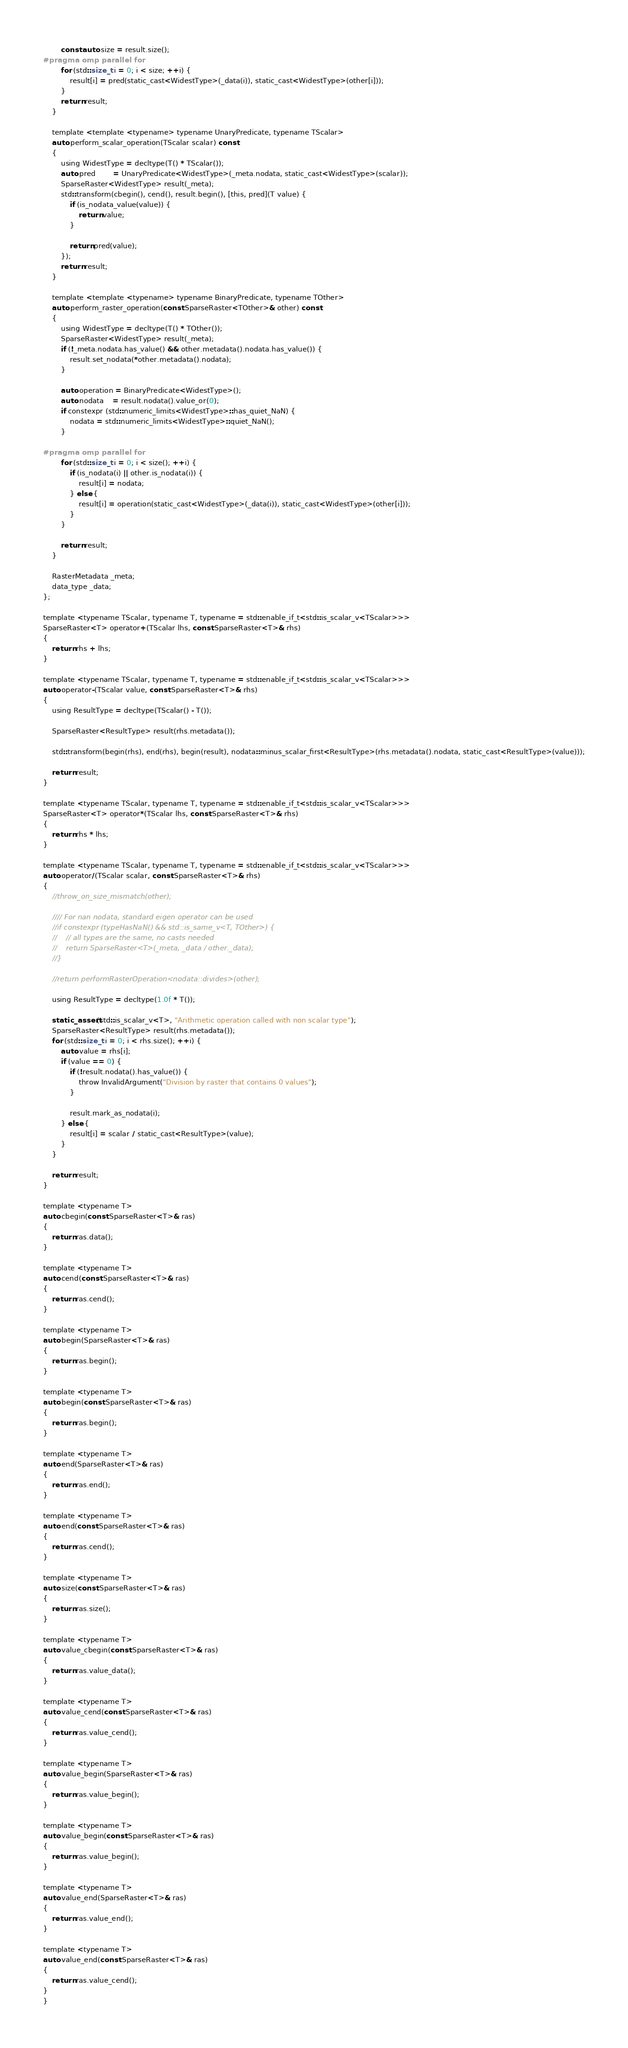<code> <loc_0><loc_0><loc_500><loc_500><_C_>        const auto size = result.size();
#pragma omp parallel for
        for (std::size_t i = 0; i < size; ++i) {
            result[i] = pred(static_cast<WidestType>(_data(i)), static_cast<WidestType>(other[i]));
        }
        return result;
    }

    template <template <typename> typename UnaryPredicate, typename TScalar>
    auto perform_scalar_operation(TScalar scalar) const
    {
        using WidestType = decltype(T() * TScalar());
        auto pred        = UnaryPredicate<WidestType>(_meta.nodata, static_cast<WidestType>(scalar));
        SparseRaster<WidestType> result(_meta);
        std::transform(cbegin(), cend(), result.begin(), [this, pred](T value) {
            if (is_nodata_value(value)) {
                return value;
            }

            return pred(value);
        });
        return result;
    }

    template <template <typename> typename BinaryPredicate, typename TOther>
    auto perform_raster_operation(const SparseRaster<TOther>& other) const
    {
        using WidestType = decltype(T() * TOther());
        SparseRaster<WidestType> result(_meta);
        if (!_meta.nodata.has_value() && other.metadata().nodata.has_value()) {
            result.set_nodata(*other.metadata().nodata);
        }

        auto operation = BinaryPredicate<WidestType>();
        auto nodata    = result.nodata().value_or(0);
        if constexpr (std::numeric_limits<WidestType>::has_quiet_NaN) {
            nodata = std::numeric_limits<WidestType>::quiet_NaN();
        }

#pragma omp parallel for
        for (std::size_t i = 0; i < size(); ++i) {
            if (is_nodata(i) || other.is_nodata(i)) {
                result[i] = nodata;
            } else {
                result[i] = operation(static_cast<WidestType>(_data(i)), static_cast<WidestType>(other[i]));
            }
        }

        return result;
    }

    RasterMetadata _meta;
    data_type _data;
};

template <typename TScalar, typename T, typename = std::enable_if_t<std::is_scalar_v<TScalar>>>
SparseRaster<T> operator+(TScalar lhs, const SparseRaster<T>& rhs)
{
    return rhs + lhs;
}

template <typename TScalar, typename T, typename = std::enable_if_t<std::is_scalar_v<TScalar>>>
auto operator-(TScalar value, const SparseRaster<T>& rhs)
{
    using ResultType = decltype(TScalar() - T());

    SparseRaster<ResultType> result(rhs.metadata());

    std::transform(begin(rhs), end(rhs), begin(result), nodata::minus_scalar_first<ResultType>(rhs.metadata().nodata, static_cast<ResultType>(value)));

    return result;
}

template <typename TScalar, typename T, typename = std::enable_if_t<std::is_scalar_v<TScalar>>>
SparseRaster<T> operator*(TScalar lhs, const SparseRaster<T>& rhs)
{
    return rhs * lhs;
}

template <typename TScalar, typename T, typename = std::enable_if_t<std::is_scalar_v<TScalar>>>
auto operator/(TScalar scalar, const SparseRaster<T>& rhs)
{
    //throw_on_size_mismatch(other);

    //// For nan nodata, standard eigen operator can be used
    //if constexpr (typeHasNaN() && std::is_same_v<T, TOther>) {
    //    // all types are the same, no casts needed
    //    return SparseRaster<T>(_meta, _data / other._data);
    //}

    //return performRasterOperation<nodata::divides>(other);

    using ResultType = decltype(1.0f * T());

    static_assert(std::is_scalar_v<T>, "Arithmetic operation called with non scalar type");
    SparseRaster<ResultType> result(rhs.metadata());
    for (std::size_t i = 0; i < rhs.size(); ++i) {
        auto value = rhs[i];
        if (value == 0) {
            if (!result.nodata().has_value()) {
                throw InvalidArgument("Division by raster that contains 0 values");
            }

            result.mark_as_nodata(i);
        } else {
            result[i] = scalar / static_cast<ResultType>(value);
        }
    }

    return result;
}

template <typename T>
auto cbegin(const SparseRaster<T>& ras)
{
    return ras.data();
}

template <typename T>
auto cend(const SparseRaster<T>& ras)
{
    return ras.cend();
}

template <typename T>
auto begin(SparseRaster<T>& ras)
{
    return ras.begin();
}

template <typename T>
auto begin(const SparseRaster<T>& ras)
{
    return ras.begin();
}

template <typename T>
auto end(SparseRaster<T>& ras)
{
    return ras.end();
}

template <typename T>
auto end(const SparseRaster<T>& ras)
{
    return ras.cend();
}

template <typename T>
auto size(const SparseRaster<T>& ras)
{
    return ras.size();
}

template <typename T>
auto value_cbegin(const SparseRaster<T>& ras)
{
    return ras.value_data();
}

template <typename T>
auto value_cend(const SparseRaster<T>& ras)
{
    return ras.value_cend();
}

template <typename T>
auto value_begin(SparseRaster<T>& ras)
{
    return ras.value_begin();
}

template <typename T>
auto value_begin(const SparseRaster<T>& ras)
{
    return ras.value_begin();
}

template <typename T>
auto value_end(SparseRaster<T>& ras)
{
    return ras.value_end();
}

template <typename T>
auto value_end(const SparseRaster<T>& ras)
{
    return ras.value_cend();
}
}
</code> 